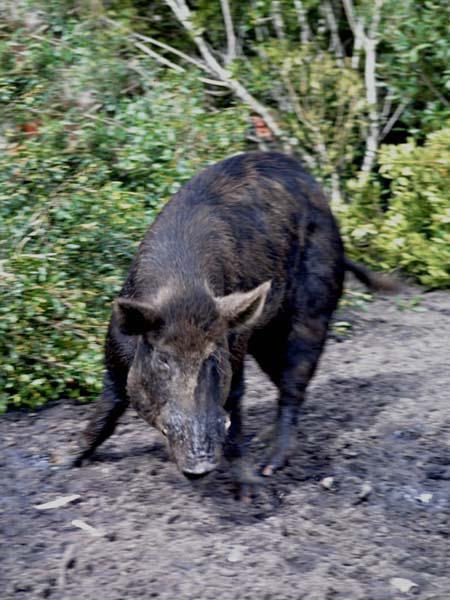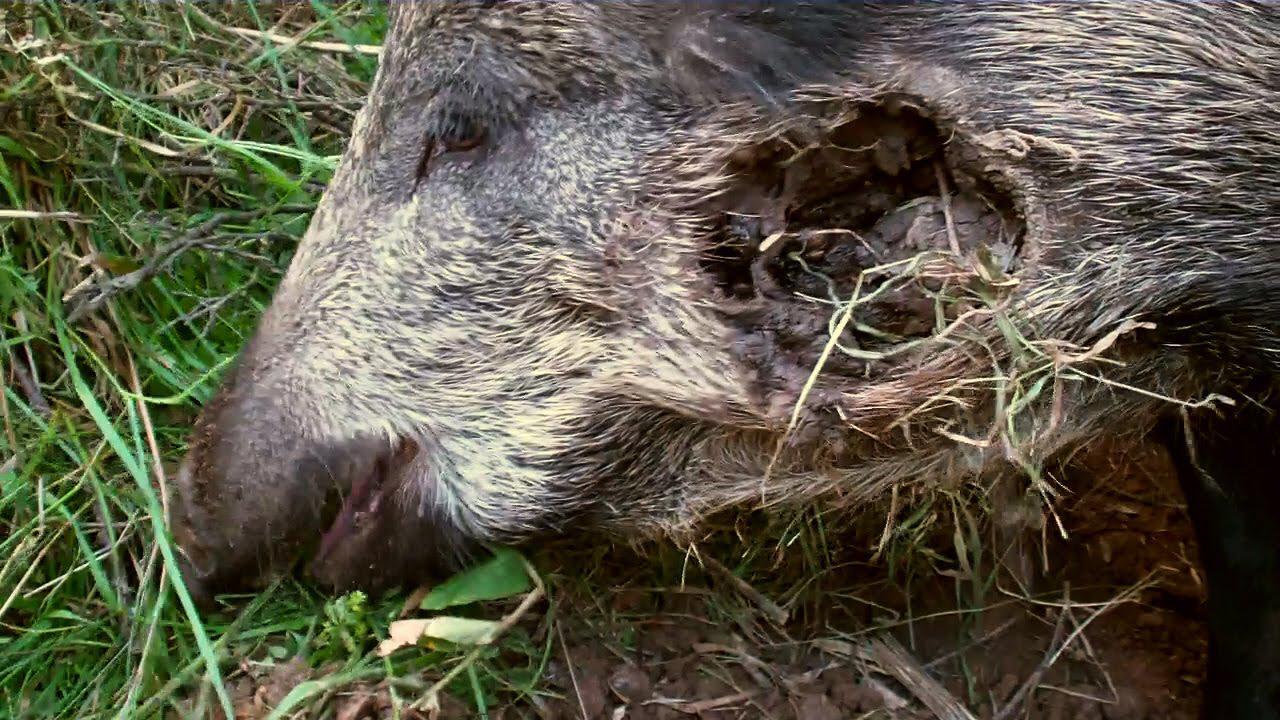The first image is the image on the left, the second image is the image on the right. Given the left and right images, does the statement "There are two animals in total." hold true? Answer yes or no. Yes. The first image is the image on the left, the second image is the image on the right. Assess this claim about the two images: "A weapon is visible next to a dead hog in one image.". Correct or not? Answer yes or no. No. 